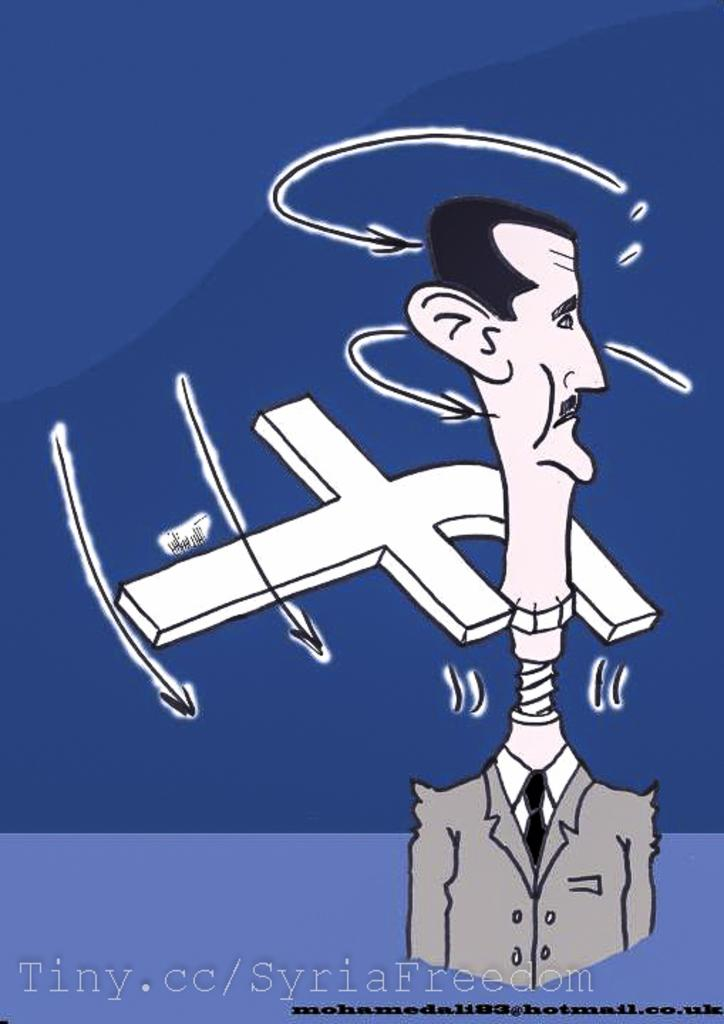Provide a one-sentence caption for the provided image. a man with a long neck and the letter F behind him. 